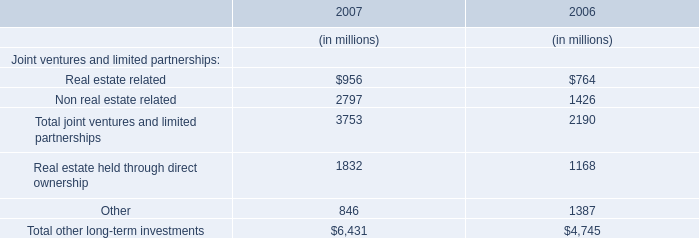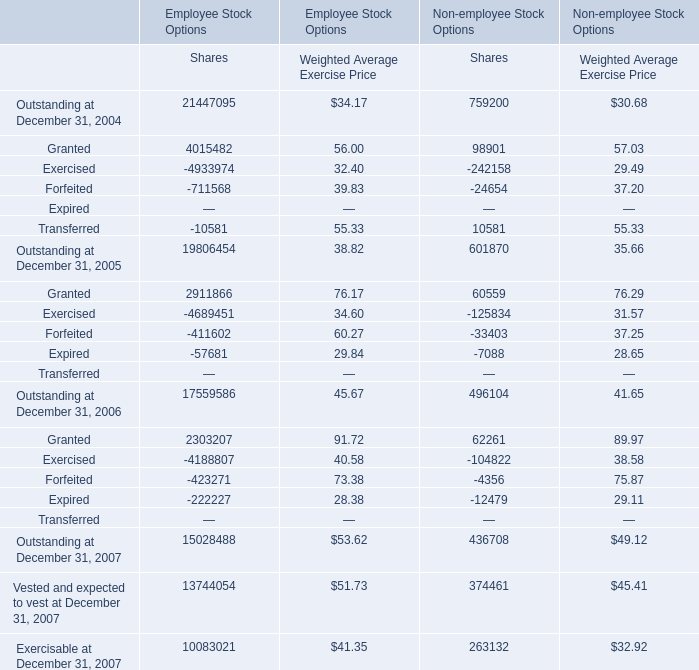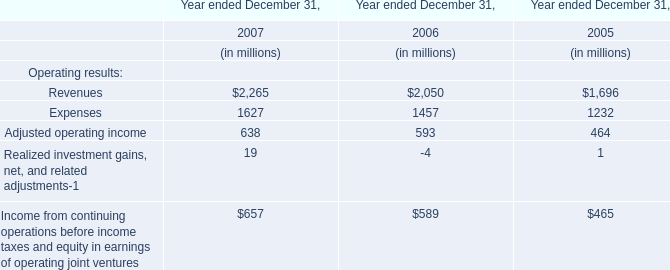what was the percentage increase in the provision for income taxes from 2009 to 2010 
Computations: (4.8 / 35.6)
Answer: 0.13483. 